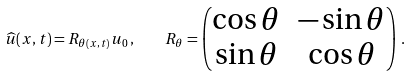<formula> <loc_0><loc_0><loc_500><loc_500>\widehat { u } ( x , t ) = { R } _ { \theta ( x , t ) } { u } _ { 0 } \, , \quad R _ { \theta } = \begin{pmatrix} \cos \theta & - \sin \theta \\ \sin \theta & \cos \theta \end{pmatrix} \, .</formula> 